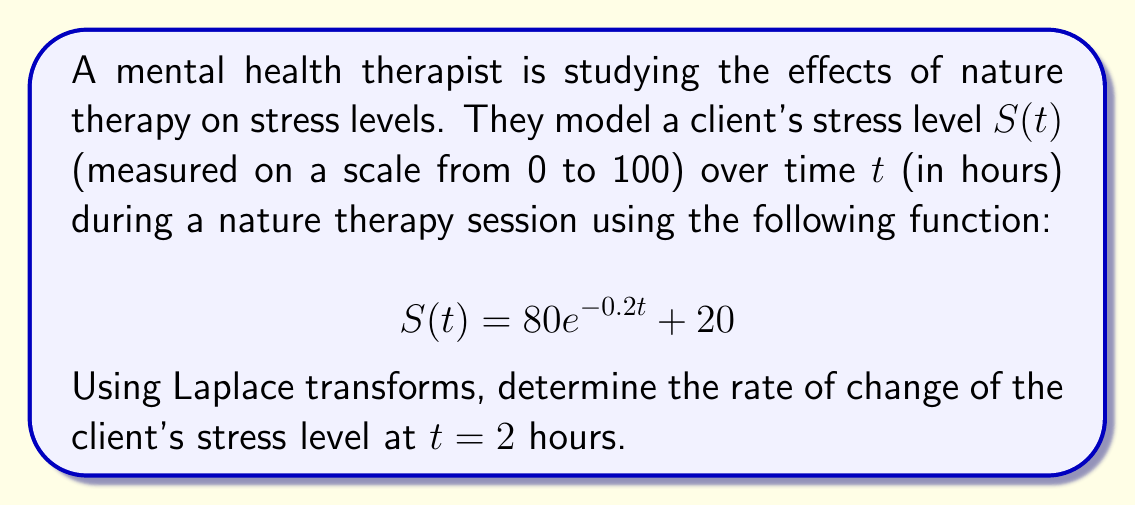What is the answer to this math problem? To solve this problem, we'll follow these steps:

1) First, we need to find the derivative of $S(t)$ to get the rate of change function.

   $$\frac{d}{dt}S(t) = \frac{d}{dt}(80e^{-0.2t} + 20) = -16e^{-0.2t}$$

2) Now, let's define $R(t) = \frac{d}{dt}S(t) = -16e^{-0.2t}$

3) We need to find the Laplace transform of $R(t)$:

   $$\mathcal{L}\{R(t)\} = \mathcal{L}\{-16e^{-0.2t}\} = -16 \cdot \frac{1}{s+0.2}$$

4) To find the rate of change at $t = 2$, we need to use the inverse Laplace transform and then evaluate at $t = 2$. However, we can use a property of the Laplace transform to simplify this process.

5) The property states that for a function $f(t)$ with Laplace transform $F(s)$:

   $$\mathcal{L}\{f(t)\} = F(s) \implies f(a) = \lim_{s \to \infty} sF(s)e^{as}$$

6) In our case, $a = 2$ and $F(s) = -16 \cdot \frac{1}{s+0.2}$

7) Applying the property:

   $$R(2) = \lim_{s \to \infty} s \cdot (-16 \cdot \frac{1}{s+0.2}) \cdot e^{2s}$$

8) Simplifying:

   $$R(2) = -16 \cdot \lim_{s \to \infty} \frac{s}{s+0.2} \cdot e^{2s} = -16 \cdot 1 \cdot e^{-0.4} = -16e^{-0.4}$$

9) Evaluating:

   $$R(2) = -16e^{-0.4} \approx -10.73$$
Answer: The rate of change of the client's stress level at $t = 2$ hours is approximately $-10.73$ units per hour. 